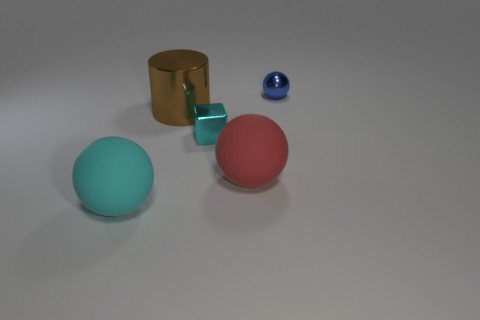Add 2 cyan rubber things. How many objects exist? 7 Subtract all spheres. How many objects are left? 2 Add 4 rubber balls. How many rubber balls are left? 6 Add 3 purple cubes. How many purple cubes exist? 3 Subtract 0 blue blocks. How many objects are left? 5 Subtract all big brown cubes. Subtract all small things. How many objects are left? 3 